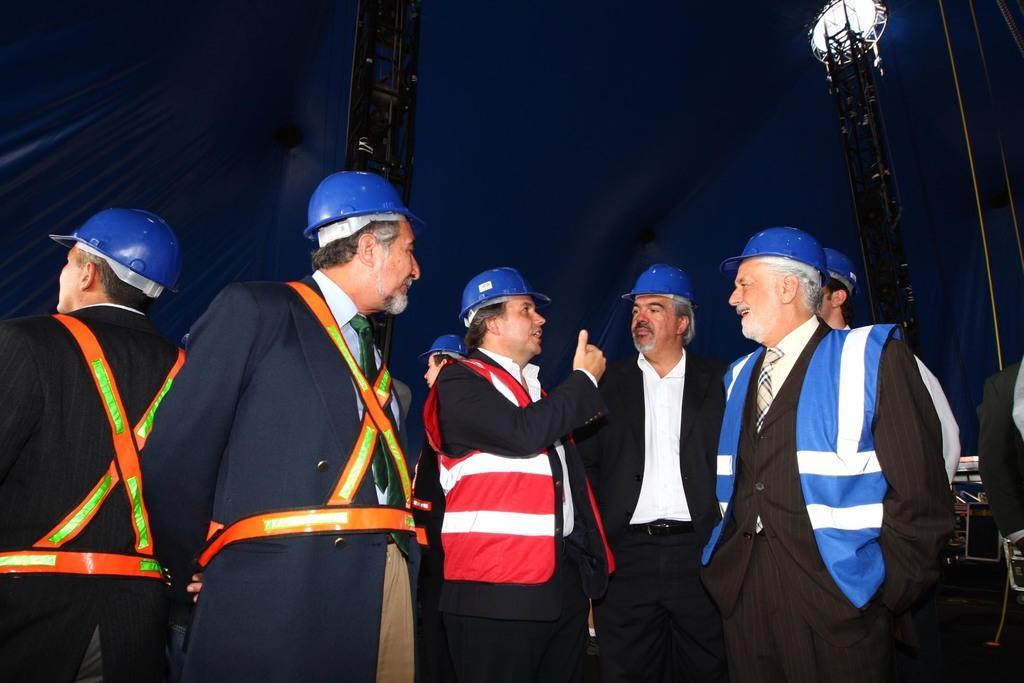In one or two sentences, can you explain what this image depicts? In the foreground of the picture there are group of people wearing helmets and taking some safety measures. In the background we can see iron frames, light, ropes, mostly it is dark. 